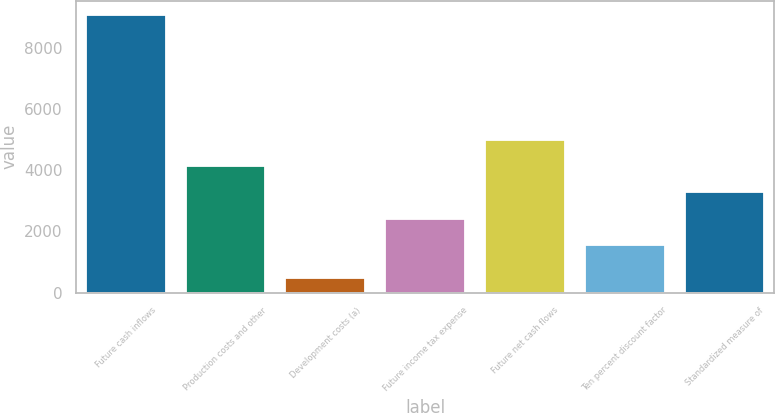<chart> <loc_0><loc_0><loc_500><loc_500><bar_chart><fcel>Future cash inflows<fcel>Production costs and other<fcel>Development costs (a)<fcel>Future income tax expense<fcel>Future net cash flows<fcel>Ten percent discount factor<fcel>Standardized measure of<nl><fcel>9076<fcel>4136.7<fcel>477<fcel>2416.9<fcel>4996.6<fcel>1557<fcel>3276.8<nl></chart> 